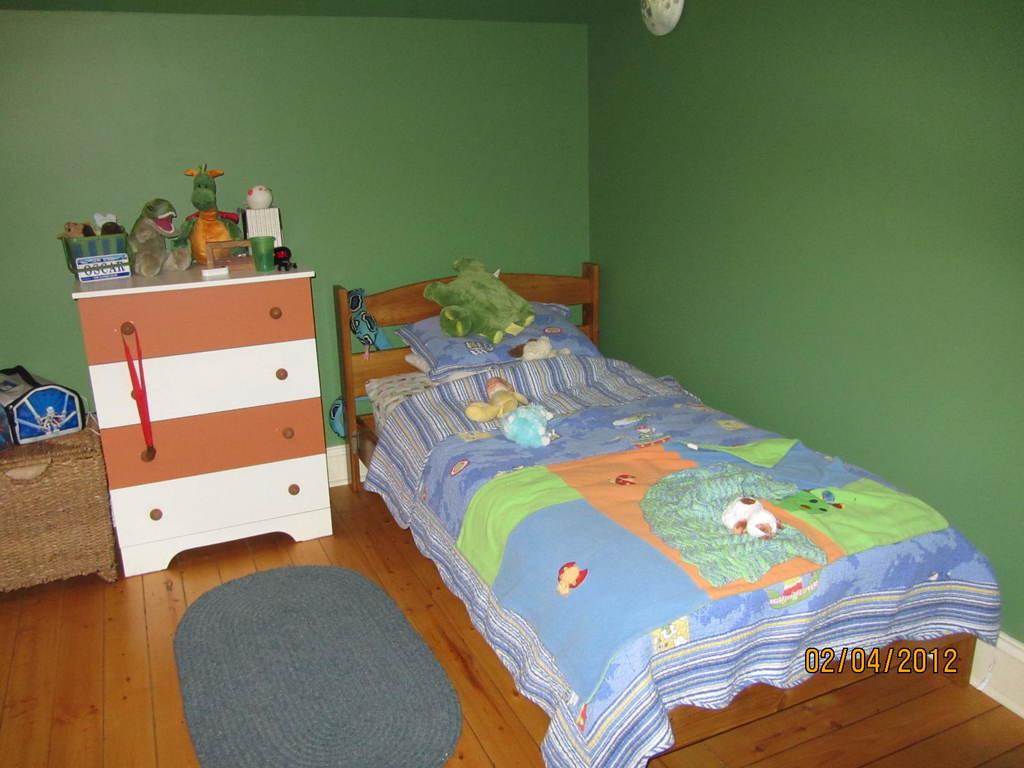What piece of furniture is present in the room? There is a bed in the room. What is placed on the bed? The bed has a pillow on it. What type of items can be found in the room? There are toys in the room. What is covering the bed? The bed has a bed sheet on it. What type of storage furniture is in the room? There are cupboards in the room. What type of award is present in the room? There is a medal in the room. What type of floor covering is in the room? There is a door mat in the room. What encloses the room? The room has walls. How many kittens are sitting on the bed in the room? There are no kittens present in the room, so it is not possible to determine their number or location. 